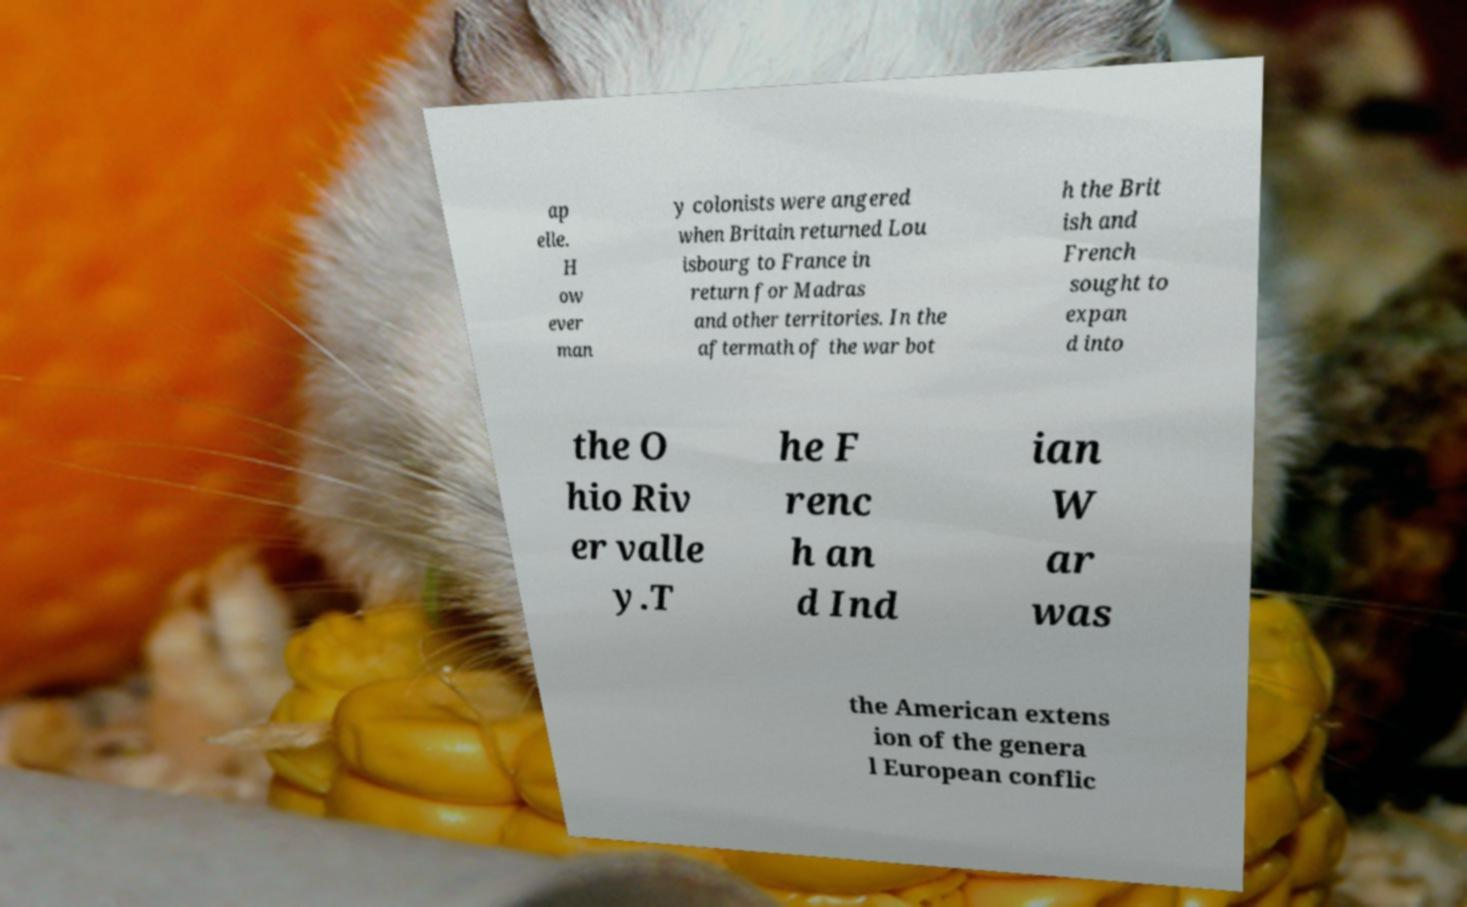What messages or text are displayed in this image? I need them in a readable, typed format. ap elle. H ow ever man y colonists were angered when Britain returned Lou isbourg to France in return for Madras and other territories. In the aftermath of the war bot h the Brit ish and French sought to expan d into the O hio Riv er valle y.T he F renc h an d Ind ian W ar was the American extens ion of the genera l European conflic 